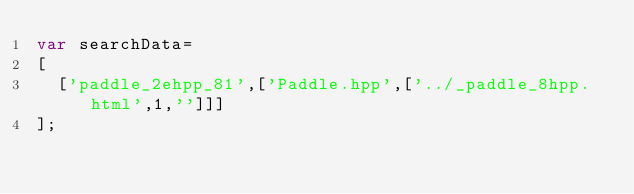<code> <loc_0><loc_0><loc_500><loc_500><_JavaScript_>var searchData=
[
  ['paddle_2ehpp_81',['Paddle.hpp',['../_paddle_8hpp.html',1,'']]]
];
</code> 